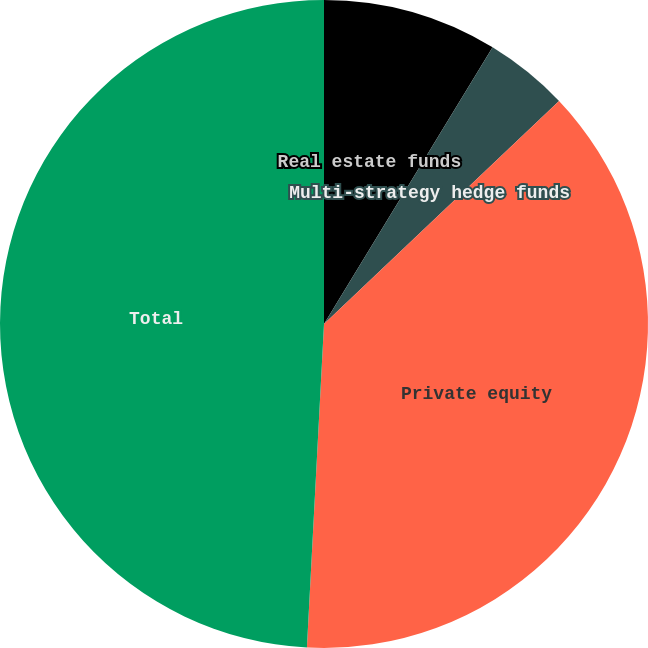Convert chart. <chart><loc_0><loc_0><loc_500><loc_500><pie_chart><fcel>Real estate funds<fcel>Multi-strategy hedge funds<fcel>Private equity<fcel>Total<nl><fcel>8.71%<fcel>4.21%<fcel>37.92%<fcel>49.16%<nl></chart> 